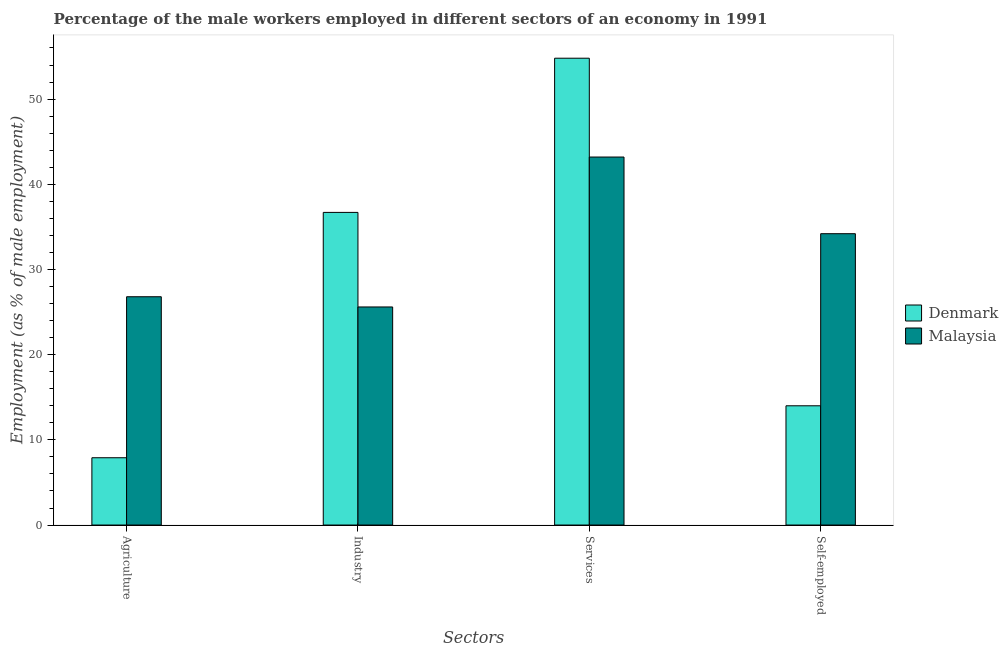How many different coloured bars are there?
Provide a succinct answer. 2. How many groups of bars are there?
Your answer should be compact. 4. What is the label of the 1st group of bars from the left?
Provide a short and direct response. Agriculture. What is the percentage of male workers in agriculture in Denmark?
Provide a short and direct response. 7.9. Across all countries, what is the maximum percentage of self employed male workers?
Offer a very short reply. 34.2. Across all countries, what is the minimum percentage of male workers in services?
Offer a very short reply. 43.2. In which country was the percentage of self employed male workers maximum?
Make the answer very short. Malaysia. What is the total percentage of male workers in industry in the graph?
Give a very brief answer. 62.3. What is the difference between the percentage of male workers in agriculture in Malaysia and that in Denmark?
Provide a succinct answer. 18.9. What is the difference between the percentage of male workers in services in Denmark and the percentage of male workers in agriculture in Malaysia?
Your answer should be very brief. 28. What is the average percentage of male workers in agriculture per country?
Your answer should be very brief. 17.35. What is the difference between the percentage of self employed male workers and percentage of male workers in services in Denmark?
Ensure brevity in your answer.  -40.8. In how many countries, is the percentage of male workers in services greater than 50 %?
Keep it short and to the point. 1. What is the ratio of the percentage of self employed male workers in Denmark to that in Malaysia?
Give a very brief answer. 0.41. Is the percentage of male workers in agriculture in Malaysia less than that in Denmark?
Your answer should be very brief. No. What is the difference between the highest and the second highest percentage of male workers in services?
Give a very brief answer. 11.6. What is the difference between the highest and the lowest percentage of self employed male workers?
Offer a terse response. 20.2. Is the sum of the percentage of male workers in services in Malaysia and Denmark greater than the maximum percentage of male workers in agriculture across all countries?
Your answer should be compact. Yes. What does the 1st bar from the left in Self-employed represents?
Your answer should be compact. Denmark. What does the 1st bar from the right in Agriculture represents?
Keep it short and to the point. Malaysia. How many bars are there?
Your response must be concise. 8. Are all the bars in the graph horizontal?
Offer a terse response. No. What is the difference between two consecutive major ticks on the Y-axis?
Make the answer very short. 10. Where does the legend appear in the graph?
Ensure brevity in your answer.  Center right. How are the legend labels stacked?
Make the answer very short. Vertical. What is the title of the graph?
Give a very brief answer. Percentage of the male workers employed in different sectors of an economy in 1991. Does "Tonga" appear as one of the legend labels in the graph?
Provide a succinct answer. No. What is the label or title of the X-axis?
Provide a short and direct response. Sectors. What is the label or title of the Y-axis?
Give a very brief answer. Employment (as % of male employment). What is the Employment (as % of male employment) in Denmark in Agriculture?
Your answer should be very brief. 7.9. What is the Employment (as % of male employment) in Malaysia in Agriculture?
Ensure brevity in your answer.  26.8. What is the Employment (as % of male employment) of Denmark in Industry?
Keep it short and to the point. 36.7. What is the Employment (as % of male employment) in Malaysia in Industry?
Keep it short and to the point. 25.6. What is the Employment (as % of male employment) of Denmark in Services?
Offer a very short reply. 54.8. What is the Employment (as % of male employment) in Malaysia in Services?
Ensure brevity in your answer.  43.2. What is the Employment (as % of male employment) of Malaysia in Self-employed?
Ensure brevity in your answer.  34.2. Across all Sectors, what is the maximum Employment (as % of male employment) of Denmark?
Make the answer very short. 54.8. Across all Sectors, what is the maximum Employment (as % of male employment) in Malaysia?
Your response must be concise. 43.2. Across all Sectors, what is the minimum Employment (as % of male employment) of Denmark?
Ensure brevity in your answer.  7.9. Across all Sectors, what is the minimum Employment (as % of male employment) in Malaysia?
Keep it short and to the point. 25.6. What is the total Employment (as % of male employment) of Denmark in the graph?
Provide a succinct answer. 113.4. What is the total Employment (as % of male employment) of Malaysia in the graph?
Provide a short and direct response. 129.8. What is the difference between the Employment (as % of male employment) of Denmark in Agriculture and that in Industry?
Your answer should be very brief. -28.8. What is the difference between the Employment (as % of male employment) of Malaysia in Agriculture and that in Industry?
Provide a succinct answer. 1.2. What is the difference between the Employment (as % of male employment) in Denmark in Agriculture and that in Services?
Offer a very short reply. -46.9. What is the difference between the Employment (as % of male employment) of Malaysia in Agriculture and that in Services?
Provide a succinct answer. -16.4. What is the difference between the Employment (as % of male employment) in Malaysia in Agriculture and that in Self-employed?
Your answer should be compact. -7.4. What is the difference between the Employment (as % of male employment) of Denmark in Industry and that in Services?
Provide a short and direct response. -18.1. What is the difference between the Employment (as % of male employment) of Malaysia in Industry and that in Services?
Offer a terse response. -17.6. What is the difference between the Employment (as % of male employment) of Denmark in Industry and that in Self-employed?
Offer a terse response. 22.7. What is the difference between the Employment (as % of male employment) in Malaysia in Industry and that in Self-employed?
Your response must be concise. -8.6. What is the difference between the Employment (as % of male employment) of Denmark in Services and that in Self-employed?
Keep it short and to the point. 40.8. What is the difference between the Employment (as % of male employment) in Malaysia in Services and that in Self-employed?
Your response must be concise. 9. What is the difference between the Employment (as % of male employment) in Denmark in Agriculture and the Employment (as % of male employment) in Malaysia in Industry?
Ensure brevity in your answer.  -17.7. What is the difference between the Employment (as % of male employment) in Denmark in Agriculture and the Employment (as % of male employment) in Malaysia in Services?
Your answer should be compact. -35.3. What is the difference between the Employment (as % of male employment) in Denmark in Agriculture and the Employment (as % of male employment) in Malaysia in Self-employed?
Offer a very short reply. -26.3. What is the difference between the Employment (as % of male employment) in Denmark in Industry and the Employment (as % of male employment) in Malaysia in Self-employed?
Offer a terse response. 2.5. What is the difference between the Employment (as % of male employment) in Denmark in Services and the Employment (as % of male employment) in Malaysia in Self-employed?
Ensure brevity in your answer.  20.6. What is the average Employment (as % of male employment) in Denmark per Sectors?
Provide a succinct answer. 28.35. What is the average Employment (as % of male employment) of Malaysia per Sectors?
Make the answer very short. 32.45. What is the difference between the Employment (as % of male employment) of Denmark and Employment (as % of male employment) of Malaysia in Agriculture?
Make the answer very short. -18.9. What is the difference between the Employment (as % of male employment) in Denmark and Employment (as % of male employment) in Malaysia in Industry?
Provide a short and direct response. 11.1. What is the difference between the Employment (as % of male employment) in Denmark and Employment (as % of male employment) in Malaysia in Services?
Give a very brief answer. 11.6. What is the difference between the Employment (as % of male employment) in Denmark and Employment (as % of male employment) in Malaysia in Self-employed?
Your answer should be compact. -20.2. What is the ratio of the Employment (as % of male employment) of Denmark in Agriculture to that in Industry?
Keep it short and to the point. 0.22. What is the ratio of the Employment (as % of male employment) of Malaysia in Agriculture to that in Industry?
Your answer should be compact. 1.05. What is the ratio of the Employment (as % of male employment) in Denmark in Agriculture to that in Services?
Offer a terse response. 0.14. What is the ratio of the Employment (as % of male employment) of Malaysia in Agriculture to that in Services?
Provide a succinct answer. 0.62. What is the ratio of the Employment (as % of male employment) in Denmark in Agriculture to that in Self-employed?
Your response must be concise. 0.56. What is the ratio of the Employment (as % of male employment) of Malaysia in Agriculture to that in Self-employed?
Ensure brevity in your answer.  0.78. What is the ratio of the Employment (as % of male employment) of Denmark in Industry to that in Services?
Provide a short and direct response. 0.67. What is the ratio of the Employment (as % of male employment) of Malaysia in Industry to that in Services?
Offer a terse response. 0.59. What is the ratio of the Employment (as % of male employment) of Denmark in Industry to that in Self-employed?
Give a very brief answer. 2.62. What is the ratio of the Employment (as % of male employment) in Malaysia in Industry to that in Self-employed?
Ensure brevity in your answer.  0.75. What is the ratio of the Employment (as % of male employment) of Denmark in Services to that in Self-employed?
Your answer should be very brief. 3.91. What is the ratio of the Employment (as % of male employment) in Malaysia in Services to that in Self-employed?
Ensure brevity in your answer.  1.26. What is the difference between the highest and the second highest Employment (as % of male employment) of Denmark?
Make the answer very short. 18.1. What is the difference between the highest and the second highest Employment (as % of male employment) in Malaysia?
Make the answer very short. 9. What is the difference between the highest and the lowest Employment (as % of male employment) in Denmark?
Your answer should be very brief. 46.9. 